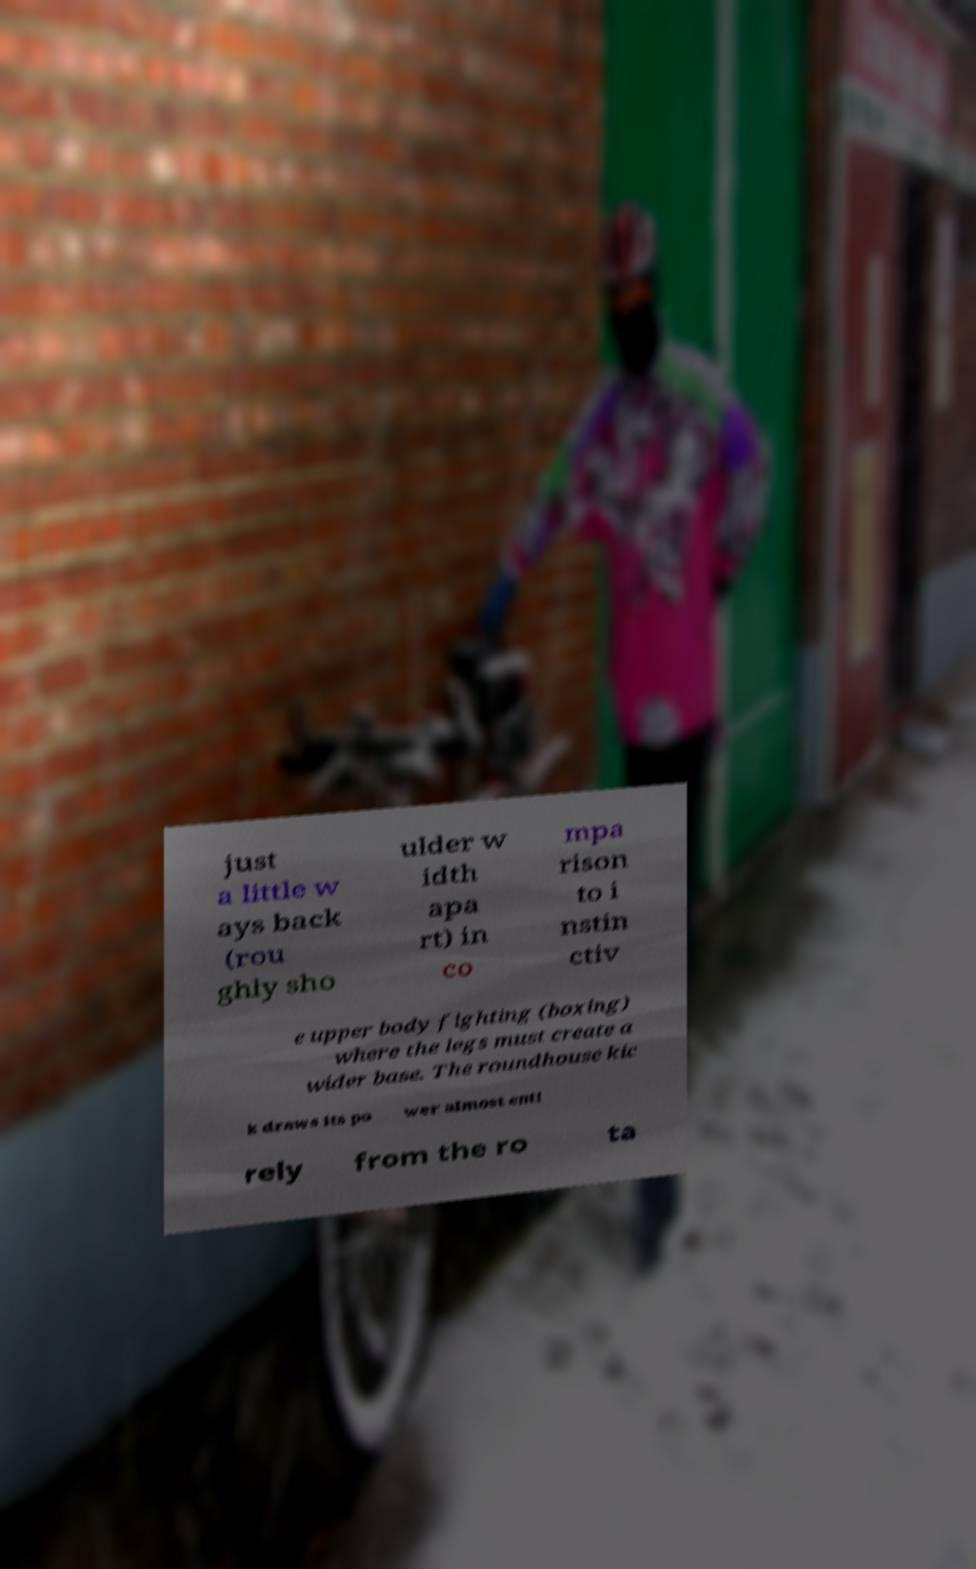Could you extract and type out the text from this image? just a little w ays back (rou ghly sho ulder w idth apa rt) in co mpa rison to i nstin ctiv e upper body fighting (boxing) where the legs must create a wider base. The roundhouse kic k draws its po wer almost enti rely from the ro ta 